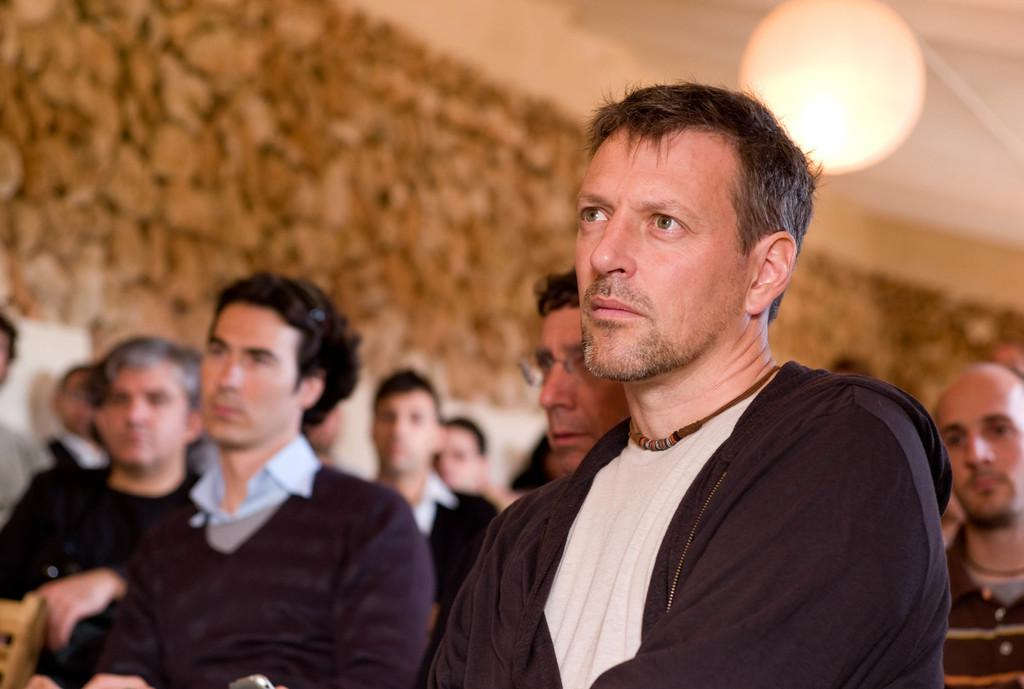What is the main subject of the image? The main subject of the image is a group of people. How can you describe the clothing of the people in the image? The people are wearing different color dresses. What can be seen in terms of lighting in the image? There is light visible in the image. Can you describe the background of the image? The background of the image is blurred. What type of plants are being used as a secretary in the image? There are no plants or secretaries present in the image. 